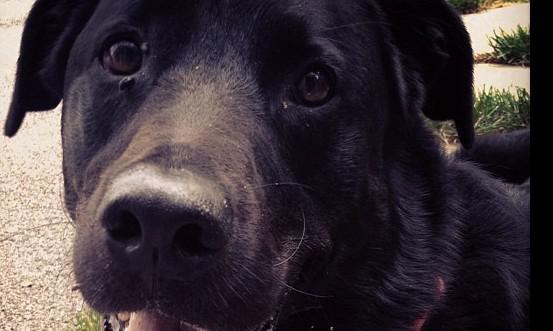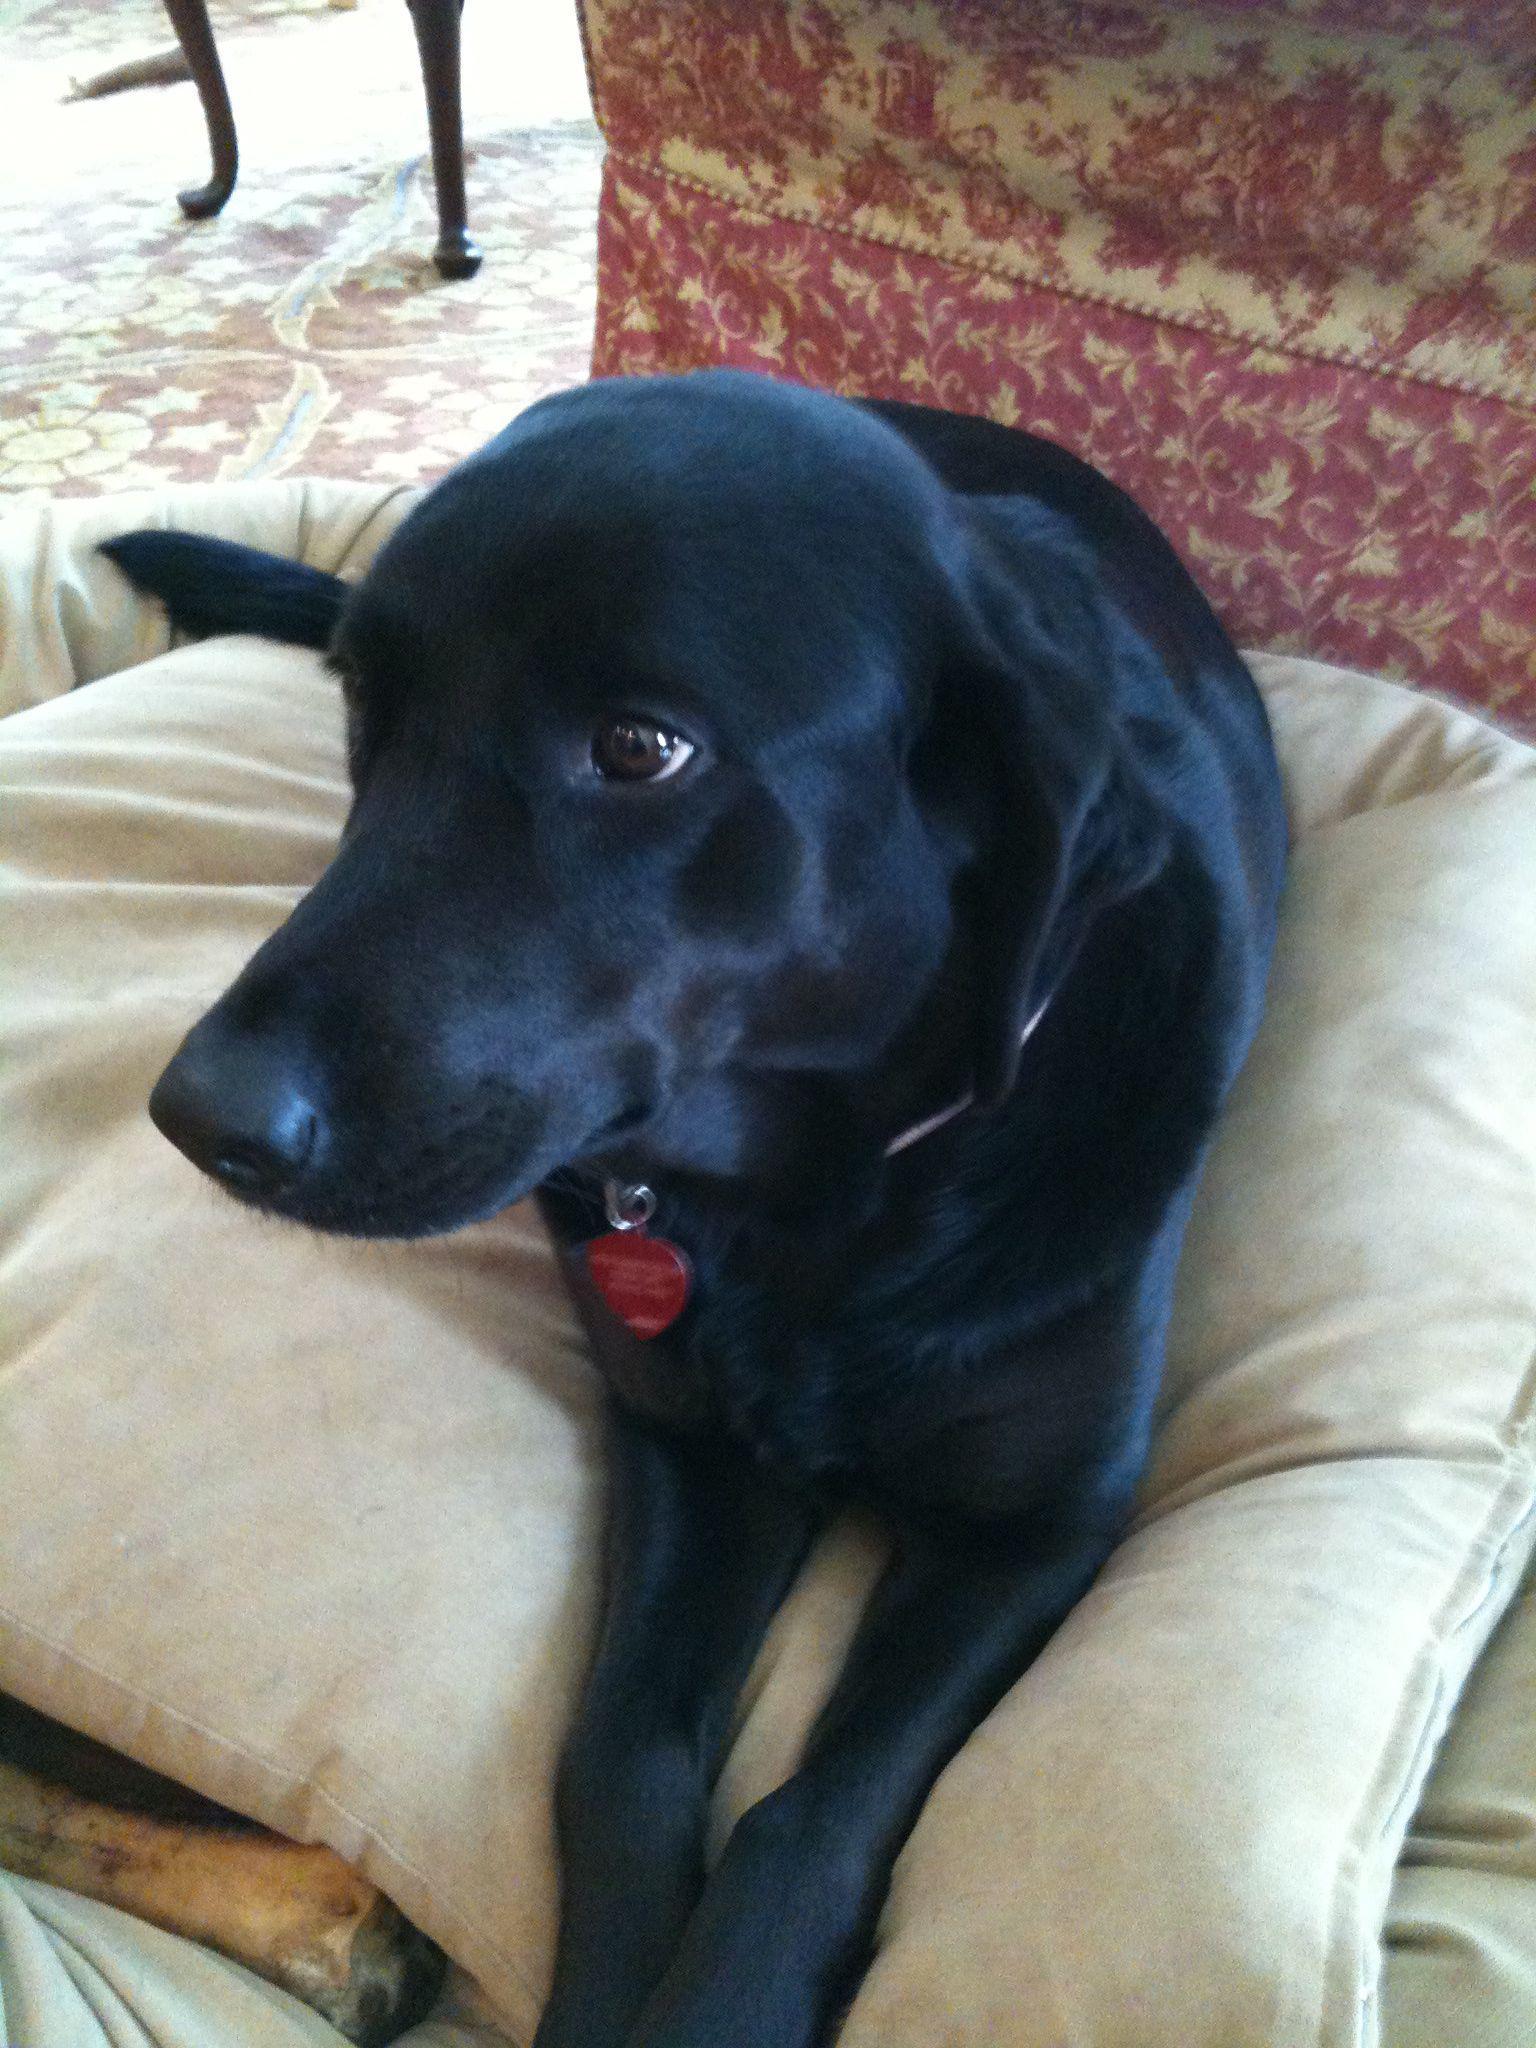The first image is the image on the left, the second image is the image on the right. For the images displayed, is the sentence "Only black labrador retrievers are shown, and one dog is in a reclining pose on something soft, and at least one dog wears a collar." factually correct? Answer yes or no. Yes. 